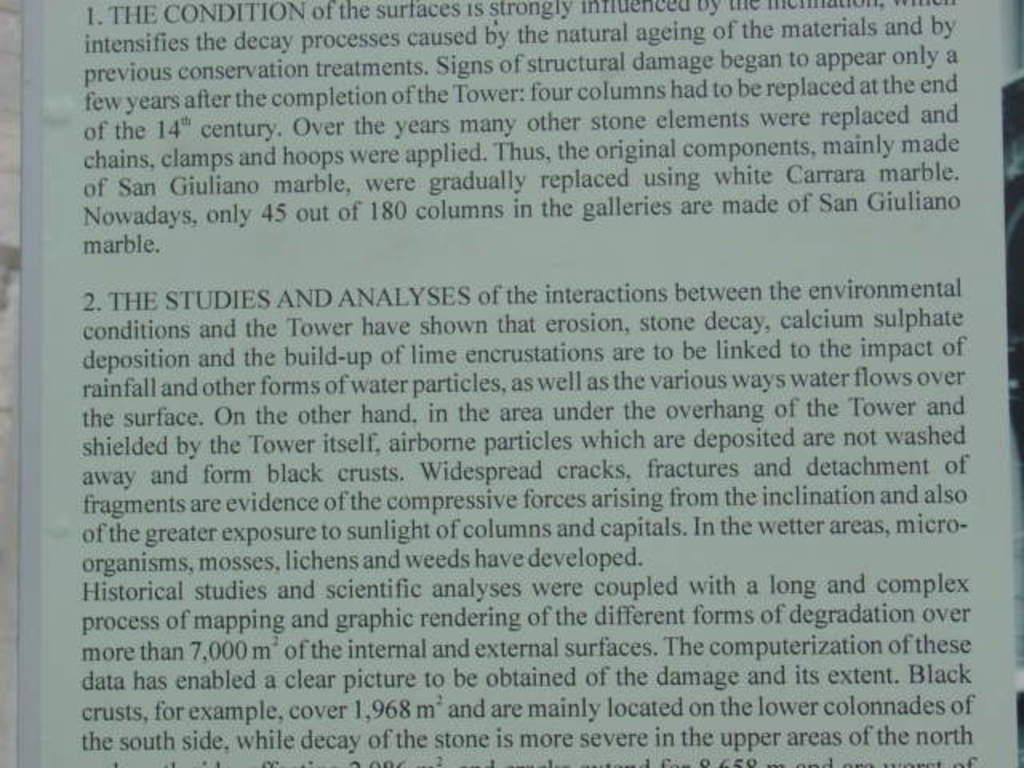Provide a one-sentence caption for the provided image. A book with a lot of writing about studies and analysis. 